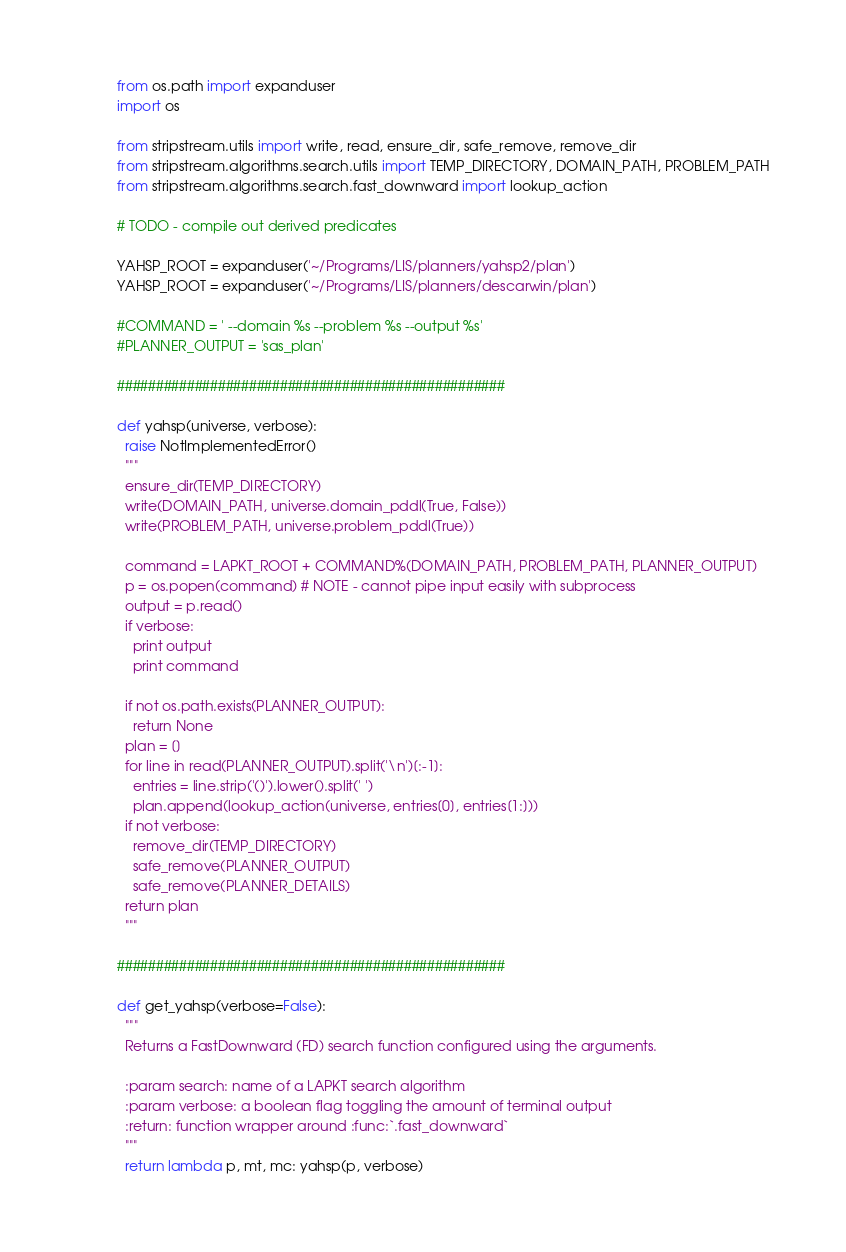<code> <loc_0><loc_0><loc_500><loc_500><_Python_>from os.path import expanduser
import os

from stripstream.utils import write, read, ensure_dir, safe_remove, remove_dir
from stripstream.algorithms.search.utils import TEMP_DIRECTORY, DOMAIN_PATH, PROBLEM_PATH
from stripstream.algorithms.search.fast_downward import lookup_action

# TODO - compile out derived predicates

YAHSP_ROOT = expanduser('~/Programs/LIS/planners/yahsp2/plan')
YAHSP_ROOT = expanduser('~/Programs/LIS/planners/descarwin/plan')

#COMMAND = ' --domain %s --problem %s --output %s'
#PLANNER_OUTPUT = 'sas_plan'

##################################################

def yahsp(universe, verbose):
  raise NotImplementedError()
  """
  ensure_dir(TEMP_DIRECTORY)
  write(DOMAIN_PATH, universe.domain_pddl(True, False))
  write(PROBLEM_PATH, universe.problem_pddl(True))

  command = LAPKT_ROOT + COMMAND%(DOMAIN_PATH, PROBLEM_PATH, PLANNER_OUTPUT)
  p = os.popen(command) # NOTE - cannot pipe input easily with subprocess
  output = p.read()
  if verbose:
    print output
    print command

  if not os.path.exists(PLANNER_OUTPUT):
    return None
  plan = []
  for line in read(PLANNER_OUTPUT).split('\n')[:-1]:
    entries = line.strip('()').lower().split(' ')
    plan.append(lookup_action(universe, entries[0], entries[1:]))
  if not verbose:
    remove_dir(TEMP_DIRECTORY)
    safe_remove(PLANNER_OUTPUT)
    safe_remove(PLANNER_DETAILS)
  return plan
  """

##################################################

def get_yahsp(verbose=False):
  """
  Returns a FastDownward (FD) search function configured using the arguments.

  :param search: name of a LAPKT search algorithm
  :param verbose: a boolean flag toggling the amount of terminal output
  :return: function wrapper around :func:`.fast_downward`
  """
  return lambda p, mt, mc: yahsp(p, verbose)
</code> 